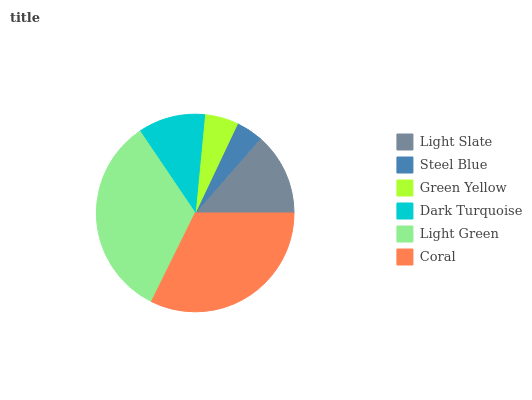Is Steel Blue the minimum?
Answer yes or no. Yes. Is Light Green the maximum?
Answer yes or no. Yes. Is Green Yellow the minimum?
Answer yes or no. No. Is Green Yellow the maximum?
Answer yes or no. No. Is Green Yellow greater than Steel Blue?
Answer yes or no. Yes. Is Steel Blue less than Green Yellow?
Answer yes or no. Yes. Is Steel Blue greater than Green Yellow?
Answer yes or no. No. Is Green Yellow less than Steel Blue?
Answer yes or no. No. Is Light Slate the high median?
Answer yes or no. Yes. Is Dark Turquoise the low median?
Answer yes or no. Yes. Is Dark Turquoise the high median?
Answer yes or no. No. Is Steel Blue the low median?
Answer yes or no. No. 